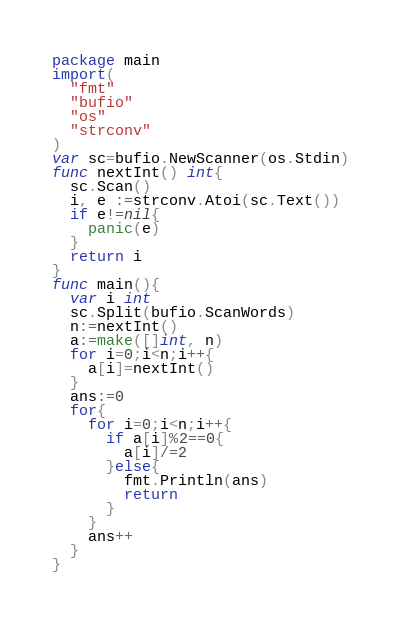Convert code to text. <code><loc_0><loc_0><loc_500><loc_500><_Go_>package main
import(
  "fmt"
  "bufio"
  "os"
  "strconv"
)
var sc=bufio.NewScanner(os.Stdin)
func nextInt() int{
  sc.Scan()
  i, e :=strconv.Atoi(sc.Text())
  if e!=nil{
    panic(e)
  }
  return i
}
func main(){
  var i int
  sc.Split(bufio.ScanWords)
  n:=nextInt()
  a:=make([]int, n)
  for i=0;i<n;i++{
    a[i]=nextInt()
  }
  ans:=0
  for{
    for i=0;i<n;i++{
      if a[i]%2==0{
        a[i]/=2
      }else{
        fmt.Println(ans)
        return
      }
    }
    ans++
  }
}
</code> 